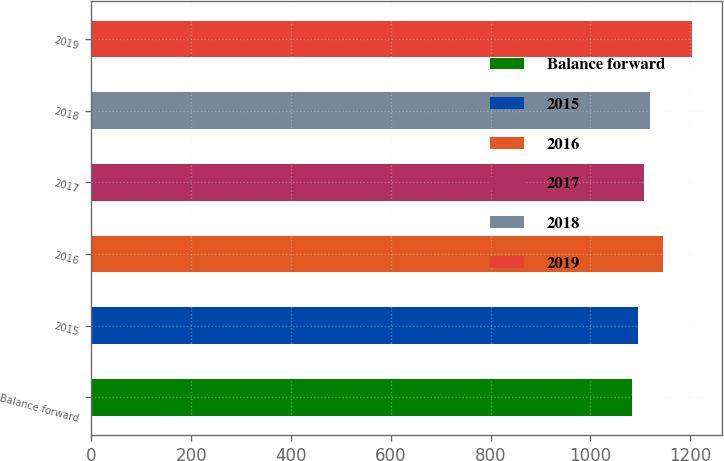Convert chart to OTSL. <chart><loc_0><loc_0><loc_500><loc_500><bar_chart><fcel>Balance forward<fcel>2015<fcel>2016<fcel>2017<fcel>2018<fcel>2019<nl><fcel>1083<fcel>1095.1<fcel>1146<fcel>1107.2<fcel>1119.3<fcel>1204<nl></chart> 